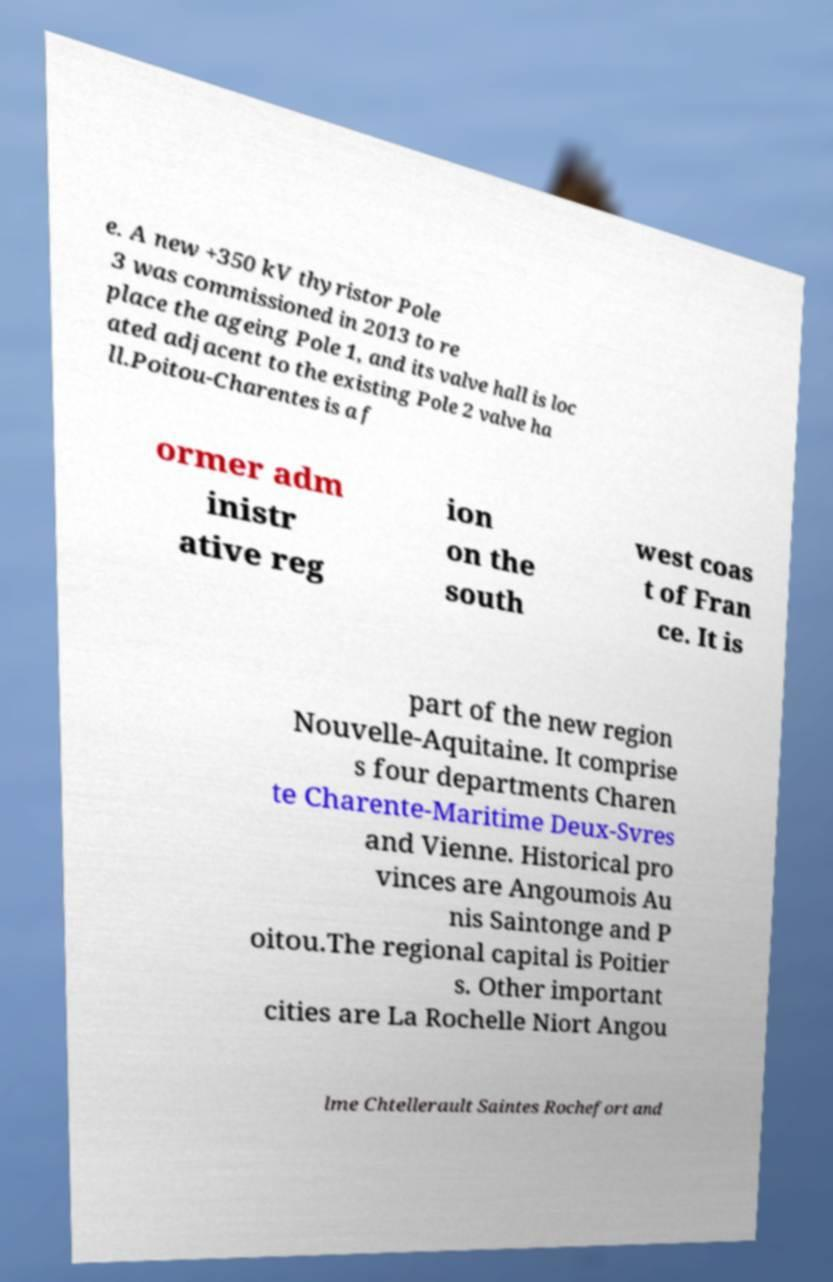Can you read and provide the text displayed in the image?This photo seems to have some interesting text. Can you extract and type it out for me? e. A new +350 kV thyristor Pole 3 was commissioned in 2013 to re place the ageing Pole 1, and its valve hall is loc ated adjacent to the existing Pole 2 valve ha ll.Poitou-Charentes is a f ormer adm inistr ative reg ion on the south west coas t of Fran ce. It is part of the new region Nouvelle-Aquitaine. It comprise s four departments Charen te Charente-Maritime Deux-Svres and Vienne. Historical pro vinces are Angoumois Au nis Saintonge and P oitou.The regional capital is Poitier s. Other important cities are La Rochelle Niort Angou lme Chtellerault Saintes Rochefort and 